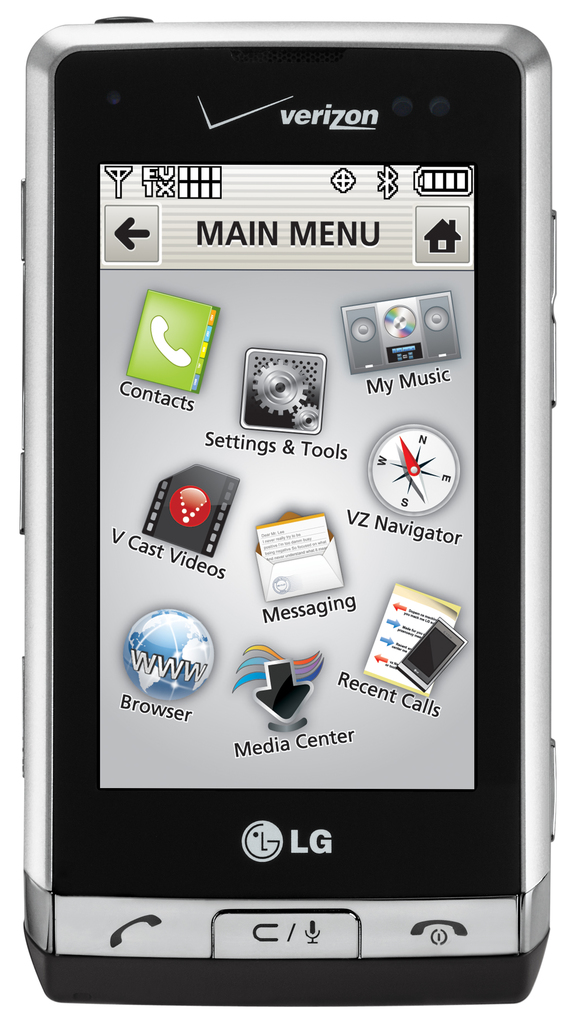What types of features does this phone offer according to the main menu? The phone offers several features including Contacts, My Music, Settings & Tools, VZ Navigator for GPS navigation, V Cast Videos for media streaming, Messaging, a Browser for internet access, and a Media Center for managing various media files. 